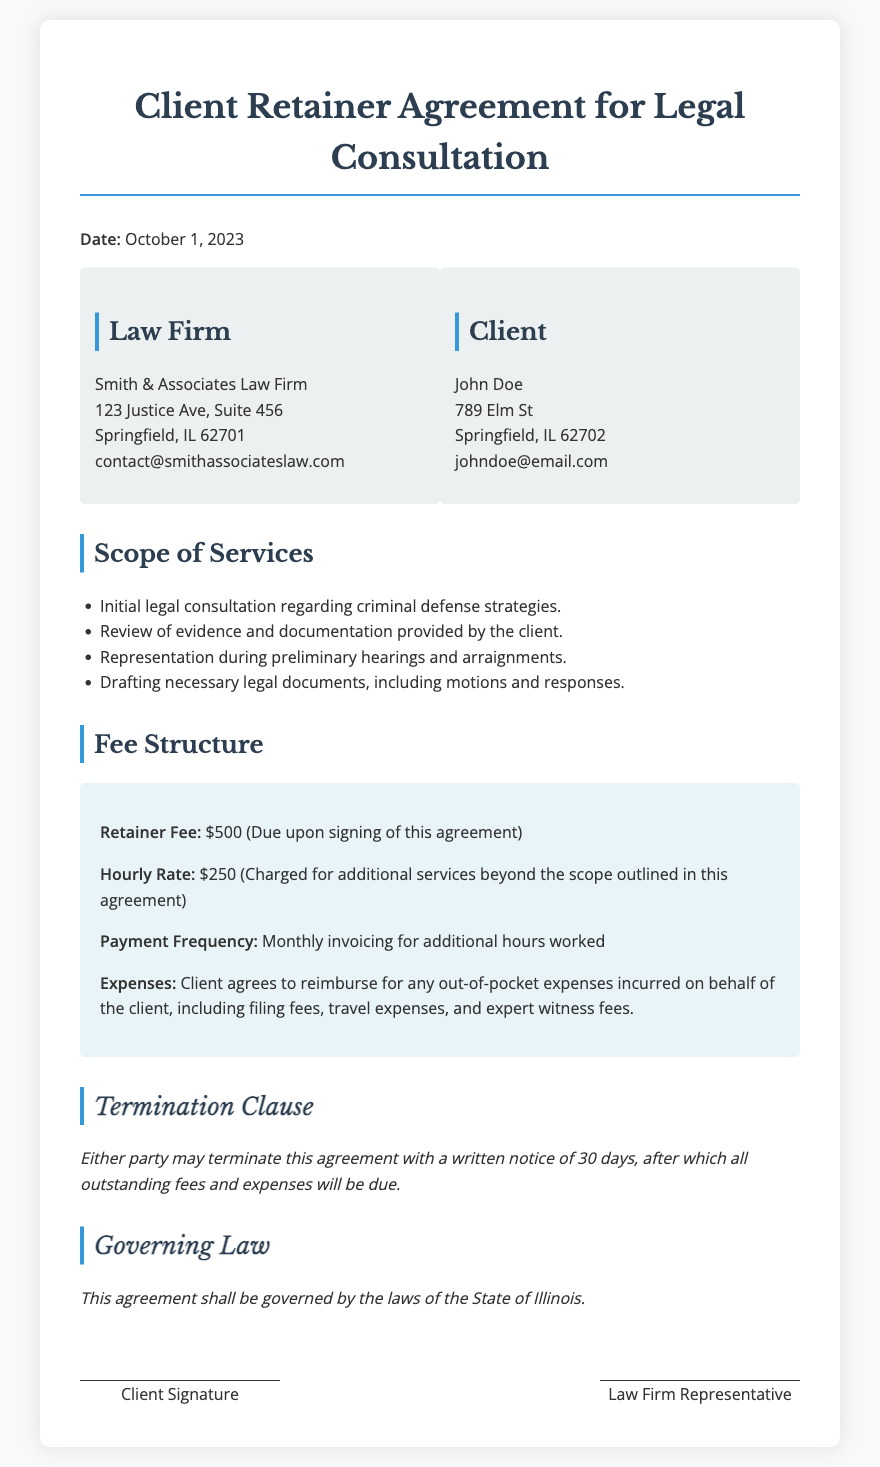What is the date of the agreement? The date of the agreement is specified in the document heading as October 1, 2023.
Answer: October 1, 2023 Who is the client? The document states that the client is John Doe, who is listed in the parties section.
Answer: John Doe What is the retainer fee? The retainer fee is mentioned directly in the fee structure section as $500.
Answer: $500 What is the hourly rate for additional services? The document specifies the hourly rate for additional services as $250 in the fee structure.
Answer: $250 How many days notice is required for termination? The termination clause states that a written notice of 30 days is required for termination.
Answer: 30 days What is included in the scope of services? Initial legal consultation, review of evidence, representation during hearings, and drafting legal documents are included in the scope of services.
Answer: Initial legal consultation, review of evidence, representation during hearings, drafting legal documents What expenses must the client reimburse? The agreement specifies that the client agrees to reimburse for filing fees, travel expenses, and expert witness fees.
Answer: Filing fees, travel expenses, expert witness fees According to the document, what law governs this agreement? The governing law section details that the agreement shall be governed by the laws of the State of Illinois.
Answer: State of Illinois What is the email address for the law firm? The email address for the law firm is provided in the parties section as contact@smithassociateslaw.com.
Answer: contact@smithassociateslaw.com 